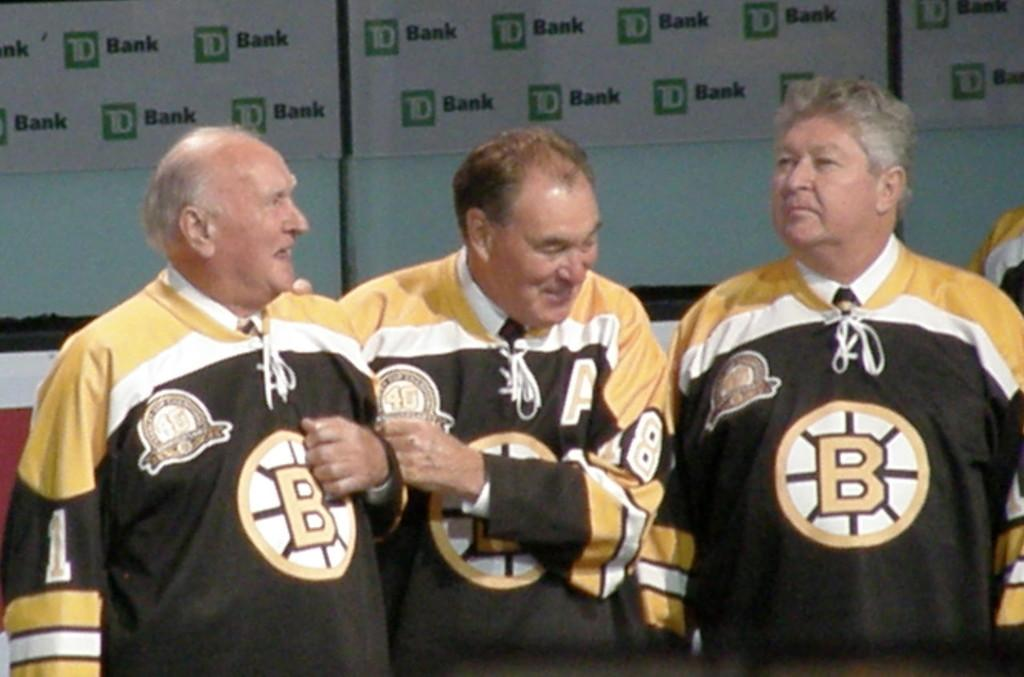<image>
Create a compact narrative representing the image presented. Three men wearing hockey jerseys in front of a banner sponsored by TD Bank. 